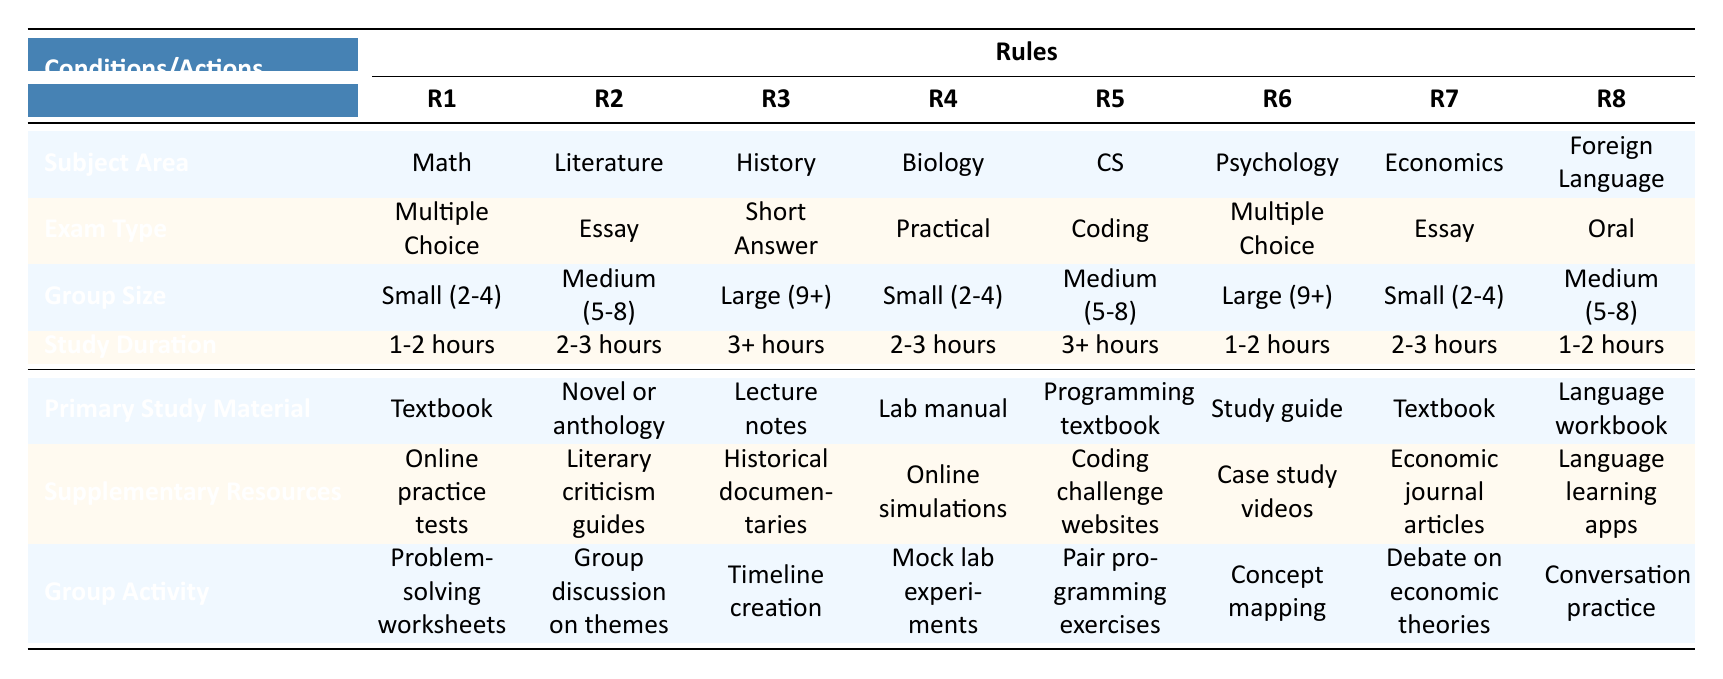What is the primary study material for Mathematics? The table directly states that for Mathematics, the primary study material is a Textbook.
Answer: Textbook Which exam type requires the longest study duration? By comparing the study durations listed, the longest duration is categorized as "3+ hours," which corresponds to History and Computer Science exams.
Answer: Short Answer, Coding Are supplementary resources provided for Biology? Yes, the table indicates that for Biology, the supplementary resources are Online simulations.
Answer: Yes What group activity is recommended for Literature? The table specifies that the group activity for Literature is a Group discussion on themes.
Answer: Group discussion on themes How many subjects have "Small (2-4)" group sizes for their study activities? To find the answer, I will count the appearances of "Small (2-4)" under Group Size. It's present for Mathematics, Biology, and Economics, totaling three subjects.
Answer: 3 Which exam type for Economics has a shorter study duration? Looking at the table, Economics has a study duration of 2-3 hours, which is shorter compared to the other subjects with "3+ hours," specifically History and Computer Science.
Answer: Essay What are the primary study materials for group sizes larger than 8? Referring to the table, Psychology and History fall into this category, with primary study materials being Study guide and Lecture notes respectively.
Answer: Study guide, Lecture notes For which subjects is the primary study material a textbook? The subjects with a primary study material of Textbook are Mathematics, Economics, and Psychology.
Answer: Mathematics, Economics, Psychology What is the recommended group activity for Computer Science and its study duration? The table shows that for Computer Science, the recommended group activity is Pair programming exercises, with a study duration of 3+ hours.
Answer: Pair programming exercises, 3+ hours 